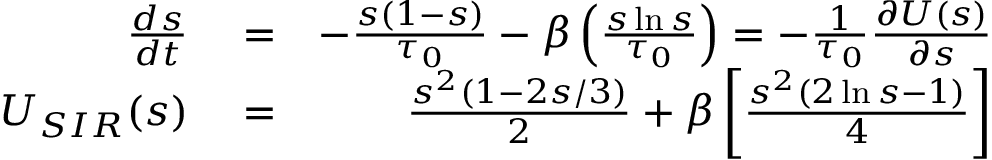Convert formula to latex. <formula><loc_0><loc_0><loc_500><loc_500>\begin{array} { r l r } { \frac { d { s } } { d t } } & = } & { - \frac { { s } ( 1 - { s } ) } { \tau _ { 0 } } - \beta \left ( \frac { s \ln { s } } { \tau _ { 0 } } \right ) = - \frac { 1 } { \tau _ { 0 } } \frac { \partial U ( s ) } { \partial s } } \\ { U _ { S I R } ( s ) } & = } & { \frac { s ^ { 2 } ( 1 - 2 s / 3 ) } { 2 } + \beta \left [ \frac { s ^ { 2 } ( 2 \ln { s } - 1 ) } { 4 } \right ] } \end{array}</formula> 